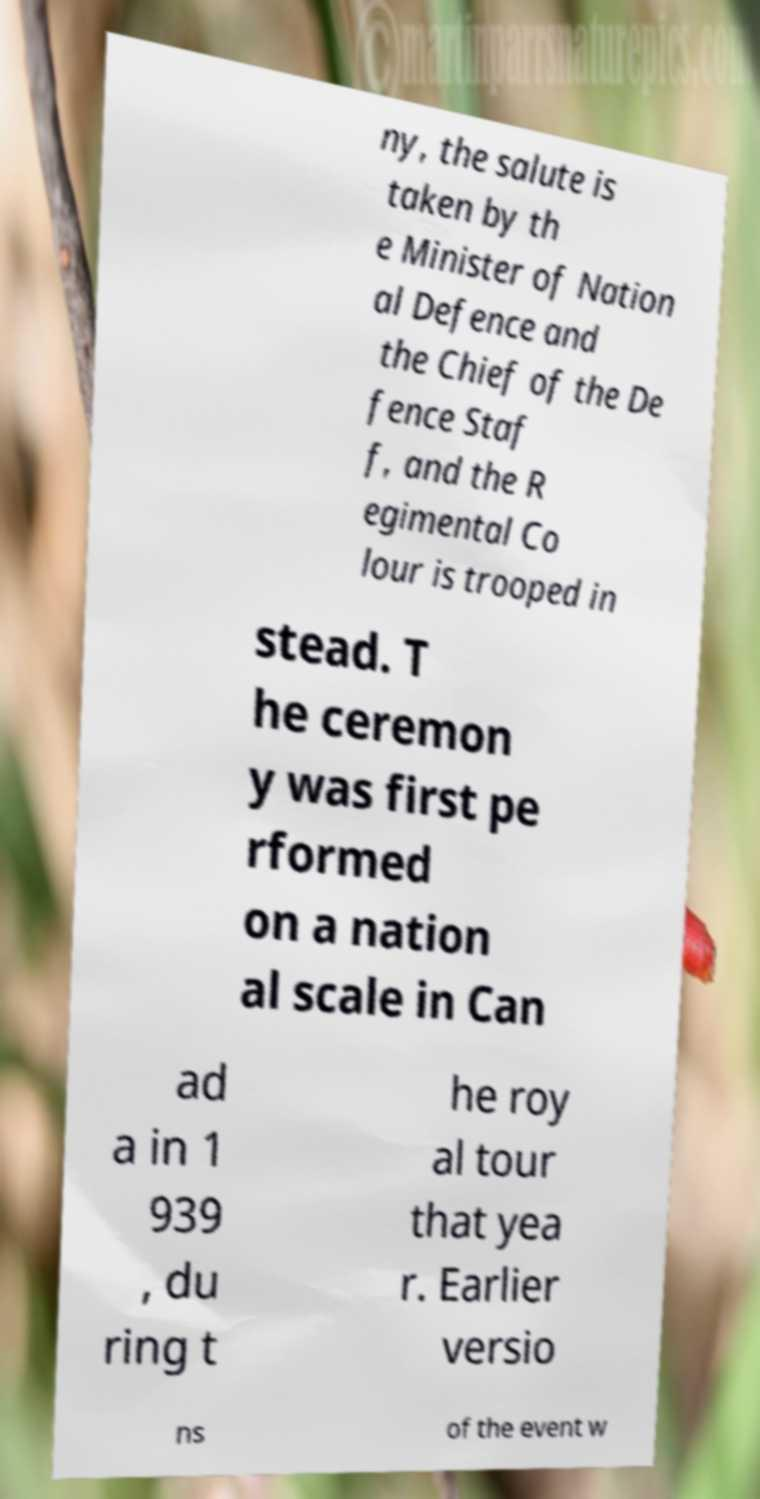Please read and relay the text visible in this image. What does it say? ny, the salute is taken by th e Minister of Nation al Defence and the Chief of the De fence Staf f, and the R egimental Co lour is trooped in stead. T he ceremon y was first pe rformed on a nation al scale in Can ad a in 1 939 , du ring t he roy al tour that yea r. Earlier versio ns of the event w 